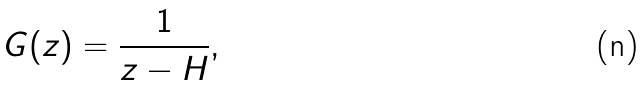<formula> <loc_0><loc_0><loc_500><loc_500>G ( z ) = \frac { 1 } { z - H } ,</formula> 